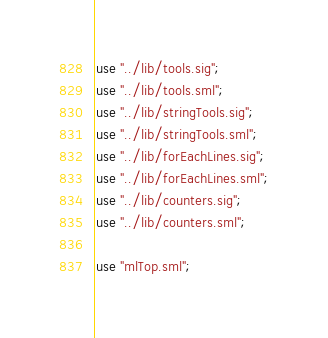<code> <loc_0><loc_0><loc_500><loc_500><_SML_>
use "../lib/tools.sig";
use "../lib/tools.sml";
use "../lib/stringTools.sig";
use "../lib/stringTools.sml";
use "../lib/forEachLines.sig";
use "../lib/forEachLines.sml";
use "../lib/counters.sig";
use "../lib/counters.sml";

use "mlTop.sml";
</code> 